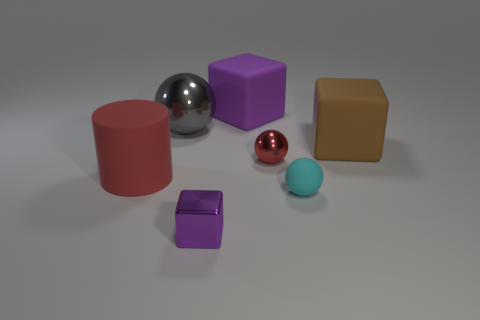How would you categorize the colors and their arrangement in this image? The colors in the image are diverse but muted, with pastel tones and a few metallic hues. The arrangement doesn't follow a particular pattern; it appears random, creating an aesthetically balanced ensemble through contrast and variation. 